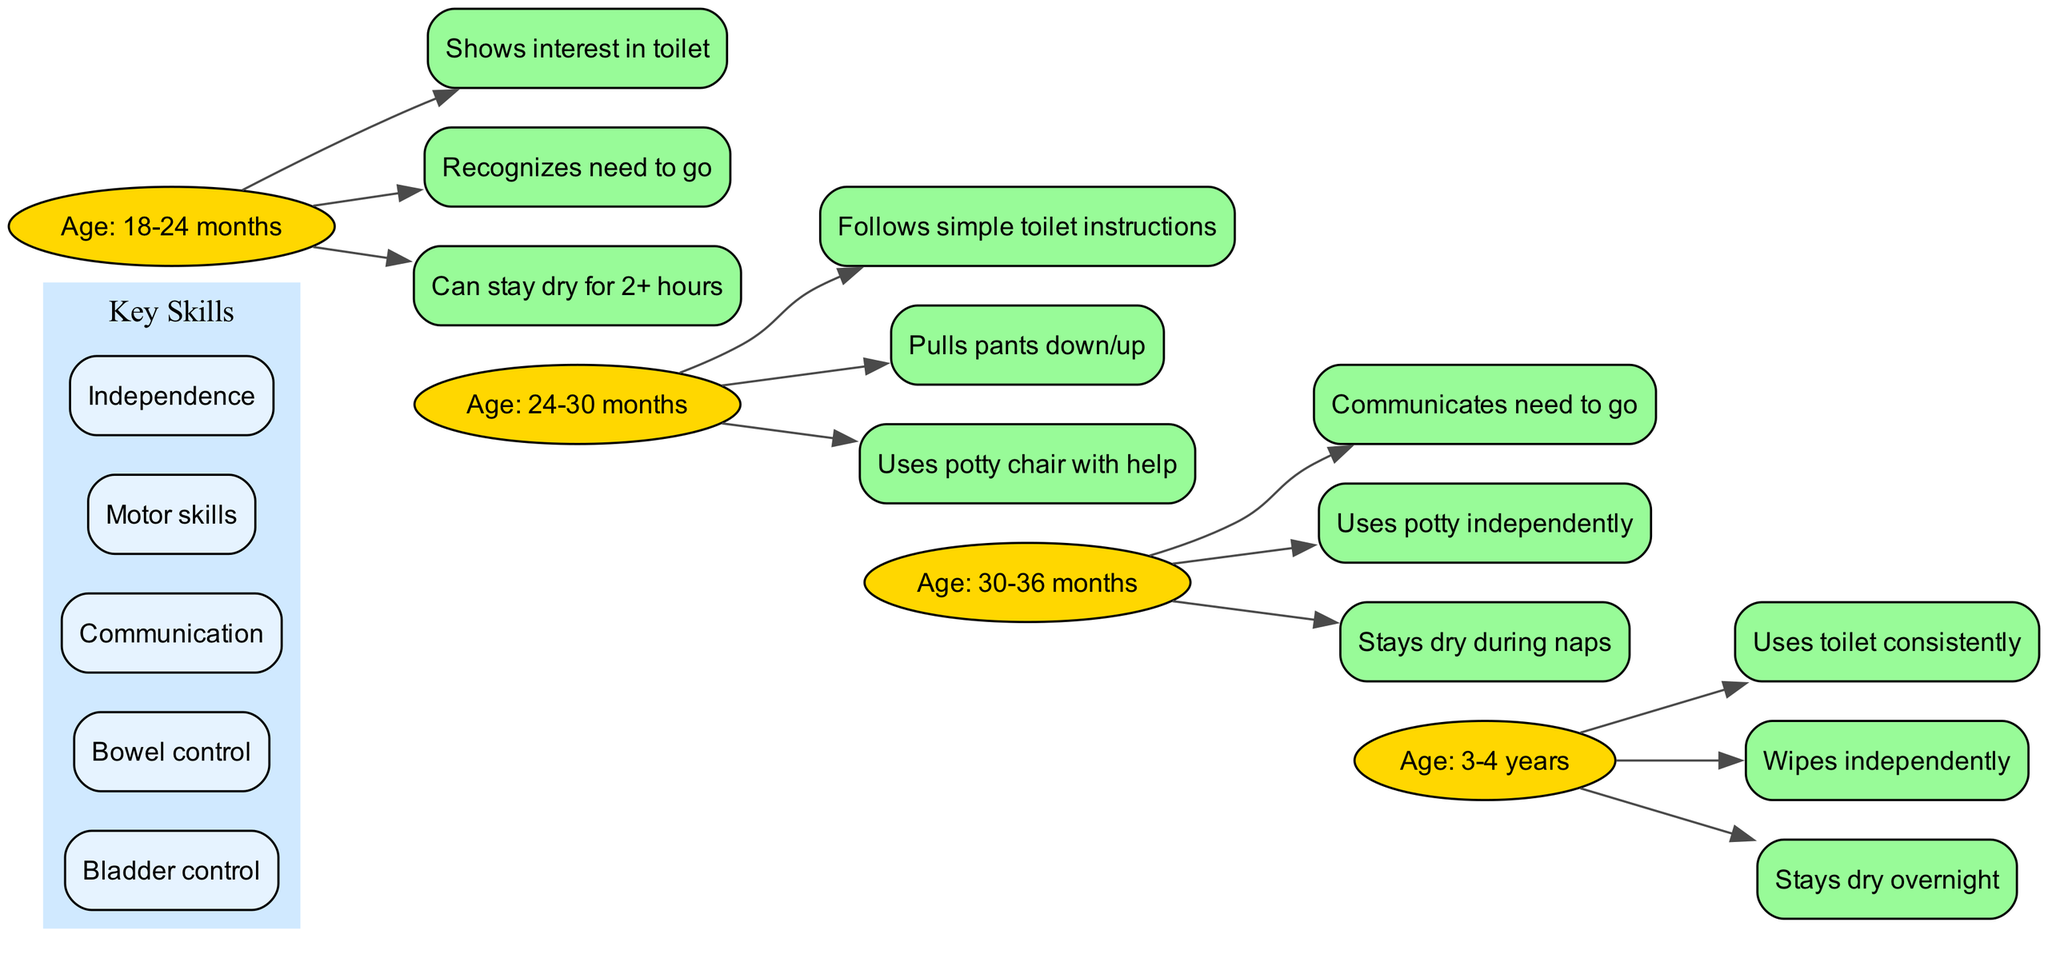What age range shows the first toilet training milestones? The diagram states that the first milestones occur between 18 to 24 months. This is described as the initial stage of the timeline before progressing to older age groups.
Answer: 18-24 months How many specific milestones are listed for the age group 30-36 months? By examining the section of the diagram covering the 30-36 months age group, it indicates three milestones are outlined. This can be counted directly from the listed achievements.
Answer: 3 What skill is associated with the ability to use the toilet independently? The diagram highlights that the skill 'Independence' is linked to the milestone of using the potty independently which falls under the age group of 30-36 months.
Answer: Independence Which milestone indicates improved communication skills for ages 24-30 months? The diagram specifies that the ability to 'Follow simple toilet instructions' signifies a communication development for the age group 24-30 months, showing both understanding and verbalization capabilities.
Answer: Follows simple toilet instructions What milestone is achieved regarding overnight dryness in children aged 3-4 years? According to the diagram, the milestone outlined for children aged 3-4 years includes 'Stays dry overnight,' demonstrating a significant advancement in toilet training.
Answer: Stays dry overnight How many age groups are identified in the timeline? The diagram categorizes four distinct age groups encompassing the entire timeline from 18 months to 4 years, incorporating a clear sequence of developmental stages.
Answer: 4 Which key skill is essential for staying dry during naps, indicated in the timeline? The diagram associates 'Bladder control' as a key skill necessary for the achievement of staying dry during naps, explicitly pointed out under the milestones listed for the 30-36 months age group.
Answer: Bladder control What is the last milestone reached before the age of 3? The diagram notes that the final milestone leading up to age 3 is 'Uses potty independently,' marking a pivotal development in the toilet training journey.
Answer: Uses potty independently How do milestones progress in relation to age groups in the diagram? The diagram illustrates a progressive structure where each subsequent age group builds upon the previous milestones, indicating that toilet training is a cumulative process with increasing independence and skill.
Answer: Cumulative progression 